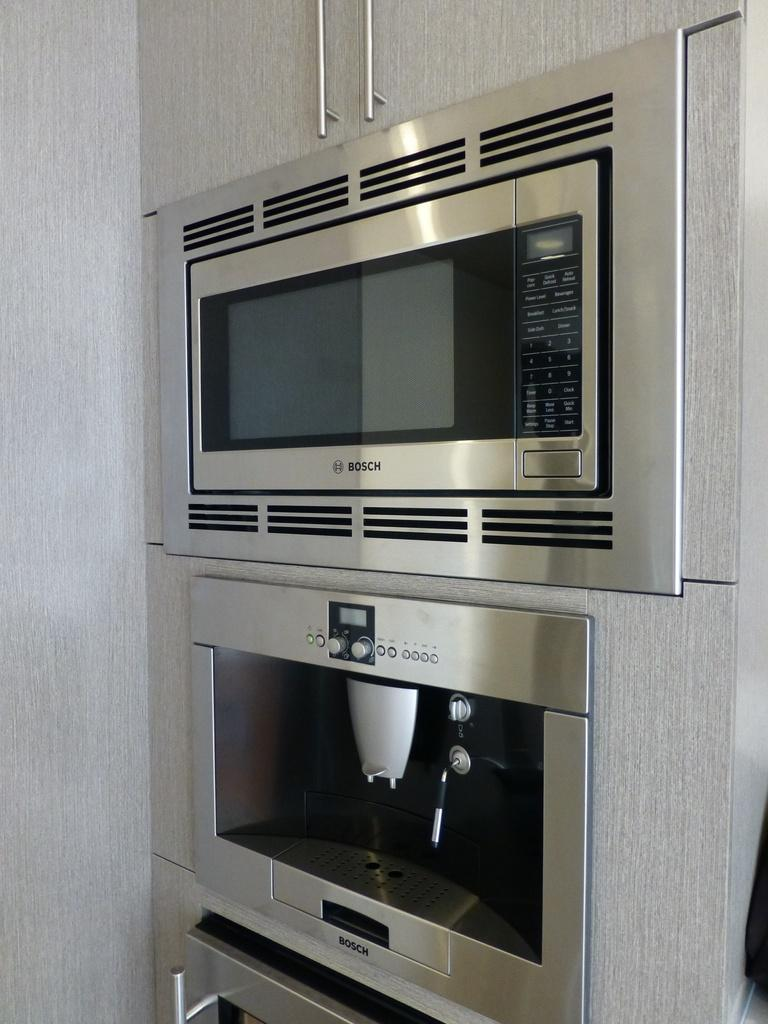<image>
Provide a brief description of the given image. A Bosch microwave sits atop a coffee maker. 